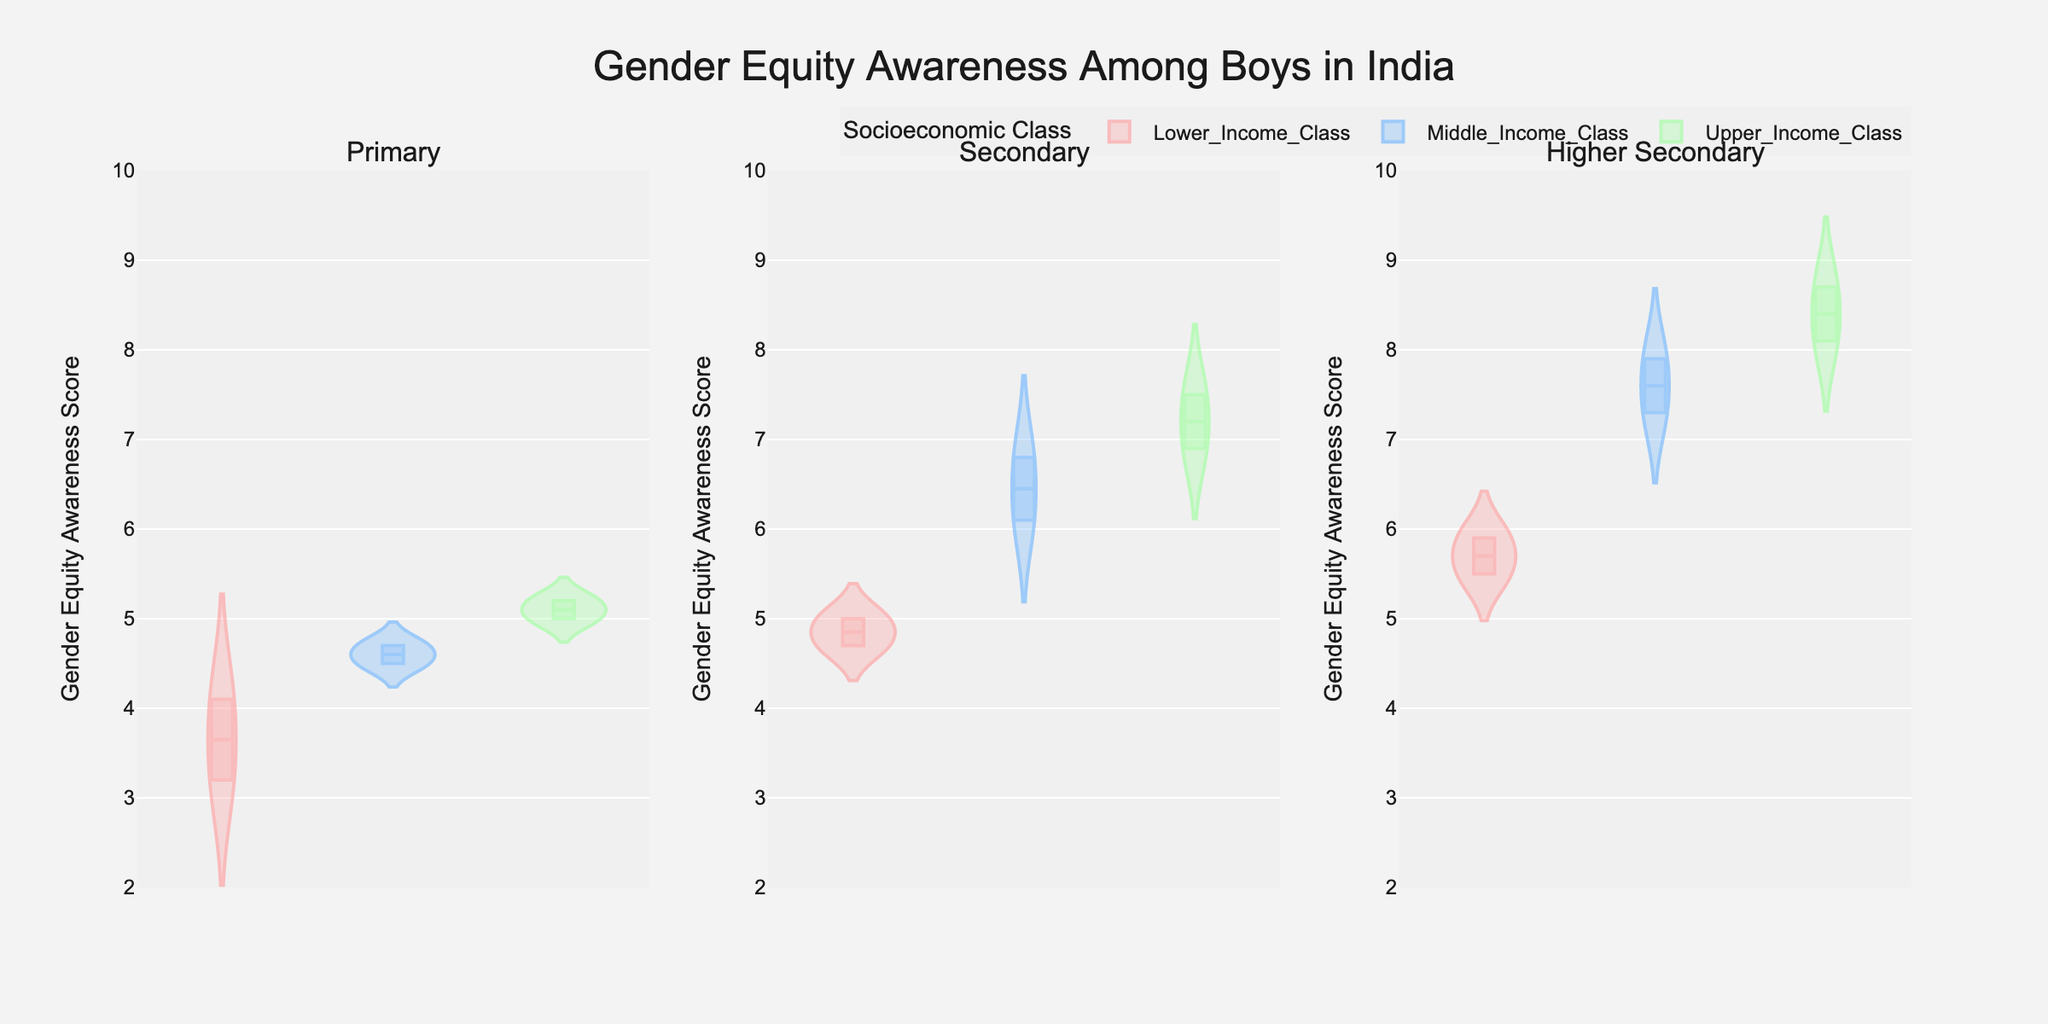What is the title of the figure? The title of the figure appears at the top, centered horizontally, and reads "Gender Equity Awareness Among Boys in India".
Answer: Gender Equity Awareness Among Boys in India What is the y-axis label of the figure? The y-axis label, which appears on the left side of each subplot, is "Gender Equity Awareness Score".
Answer: Gender Equity Awareness Score Which socioeconomic class has the highest awareness score in the Higher Secondary grade level? Looking at the Higher Secondary subplot on the right, the Upper Income Class has the highest awareness scores, with scores peaking at around 8.7.
Answer: Upper Income Class What color represents the Middle Income Class? Each socioeconomic class is represented by a different color. The Middle Income Class is represented by a blue color.
Answer: Blue How do the average scores of the Middle Income and Lower Income classes compare in the Secondary grade level? Look at the Secondary subplot in the middle, the mean lines in the violins show the Middle Income Class having a higher average score than the Lower Income Class.
Answer: Middle Income Class has a higher average score How does the gender equity awareness score vary with socioeconomic class in the Primary grade level? In the Primary subplot on the left, the Upper Income Class has higher scores, whereas the Lower Income Class shows lower scores. The Middle Income Class scores fall in between.
Answer: Upper Income Class > Middle Income Class > Lower Income Class Which socioeconomic class has the least variation in gender equity awareness scores in the Primary grade level? By examining the width of the violins in the Primary subplot, the Upper Income Class has the least variation, indicated by the narrower violin plot.
Answer: Upper Income Class How does the mean gender equity awareness score change as boys move from Primary to Higher Secondary in the Upper Income Class? Observing the subplots from left to right, the mean score in the Upper Income Class increases from Primary (~5.1) to Secondary (~7.2) to Higher Secondary (~8.4).
Answer: It increases Which socioeconomic class shows the highest median gender equity awareness score in the Secondary grade level? By evaluating the median lines in the Secondary subplot, the Upper Income Class has the highest median score, around 7.2.
Answer: Upper Income Class What is the pattern of gender equity awareness scores across all grade levels for the Lower Income Class? From Primary to Higher Secondary, the Lower Income Class shows an increasing trend in the scores: from around 3.5 in Primary, to around 4.9 in Secondary, and around 5.7 in Higher Secondary.
Answer: Increasing trend 